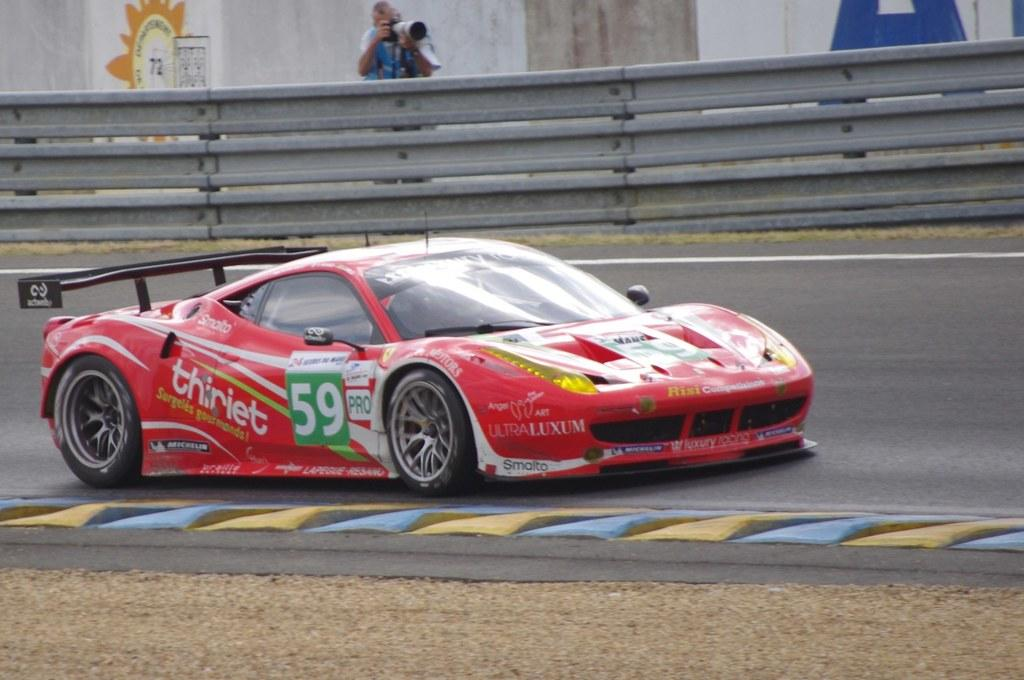What color is the car on the road in the image? The car on the road is red. What can be seen in the background of the image? There is a fencing in the image. What is the man in the image doing? The man is standing and holding a camera. What type of vest is the corn wearing in the image? There is no corn or vest present in the image. 